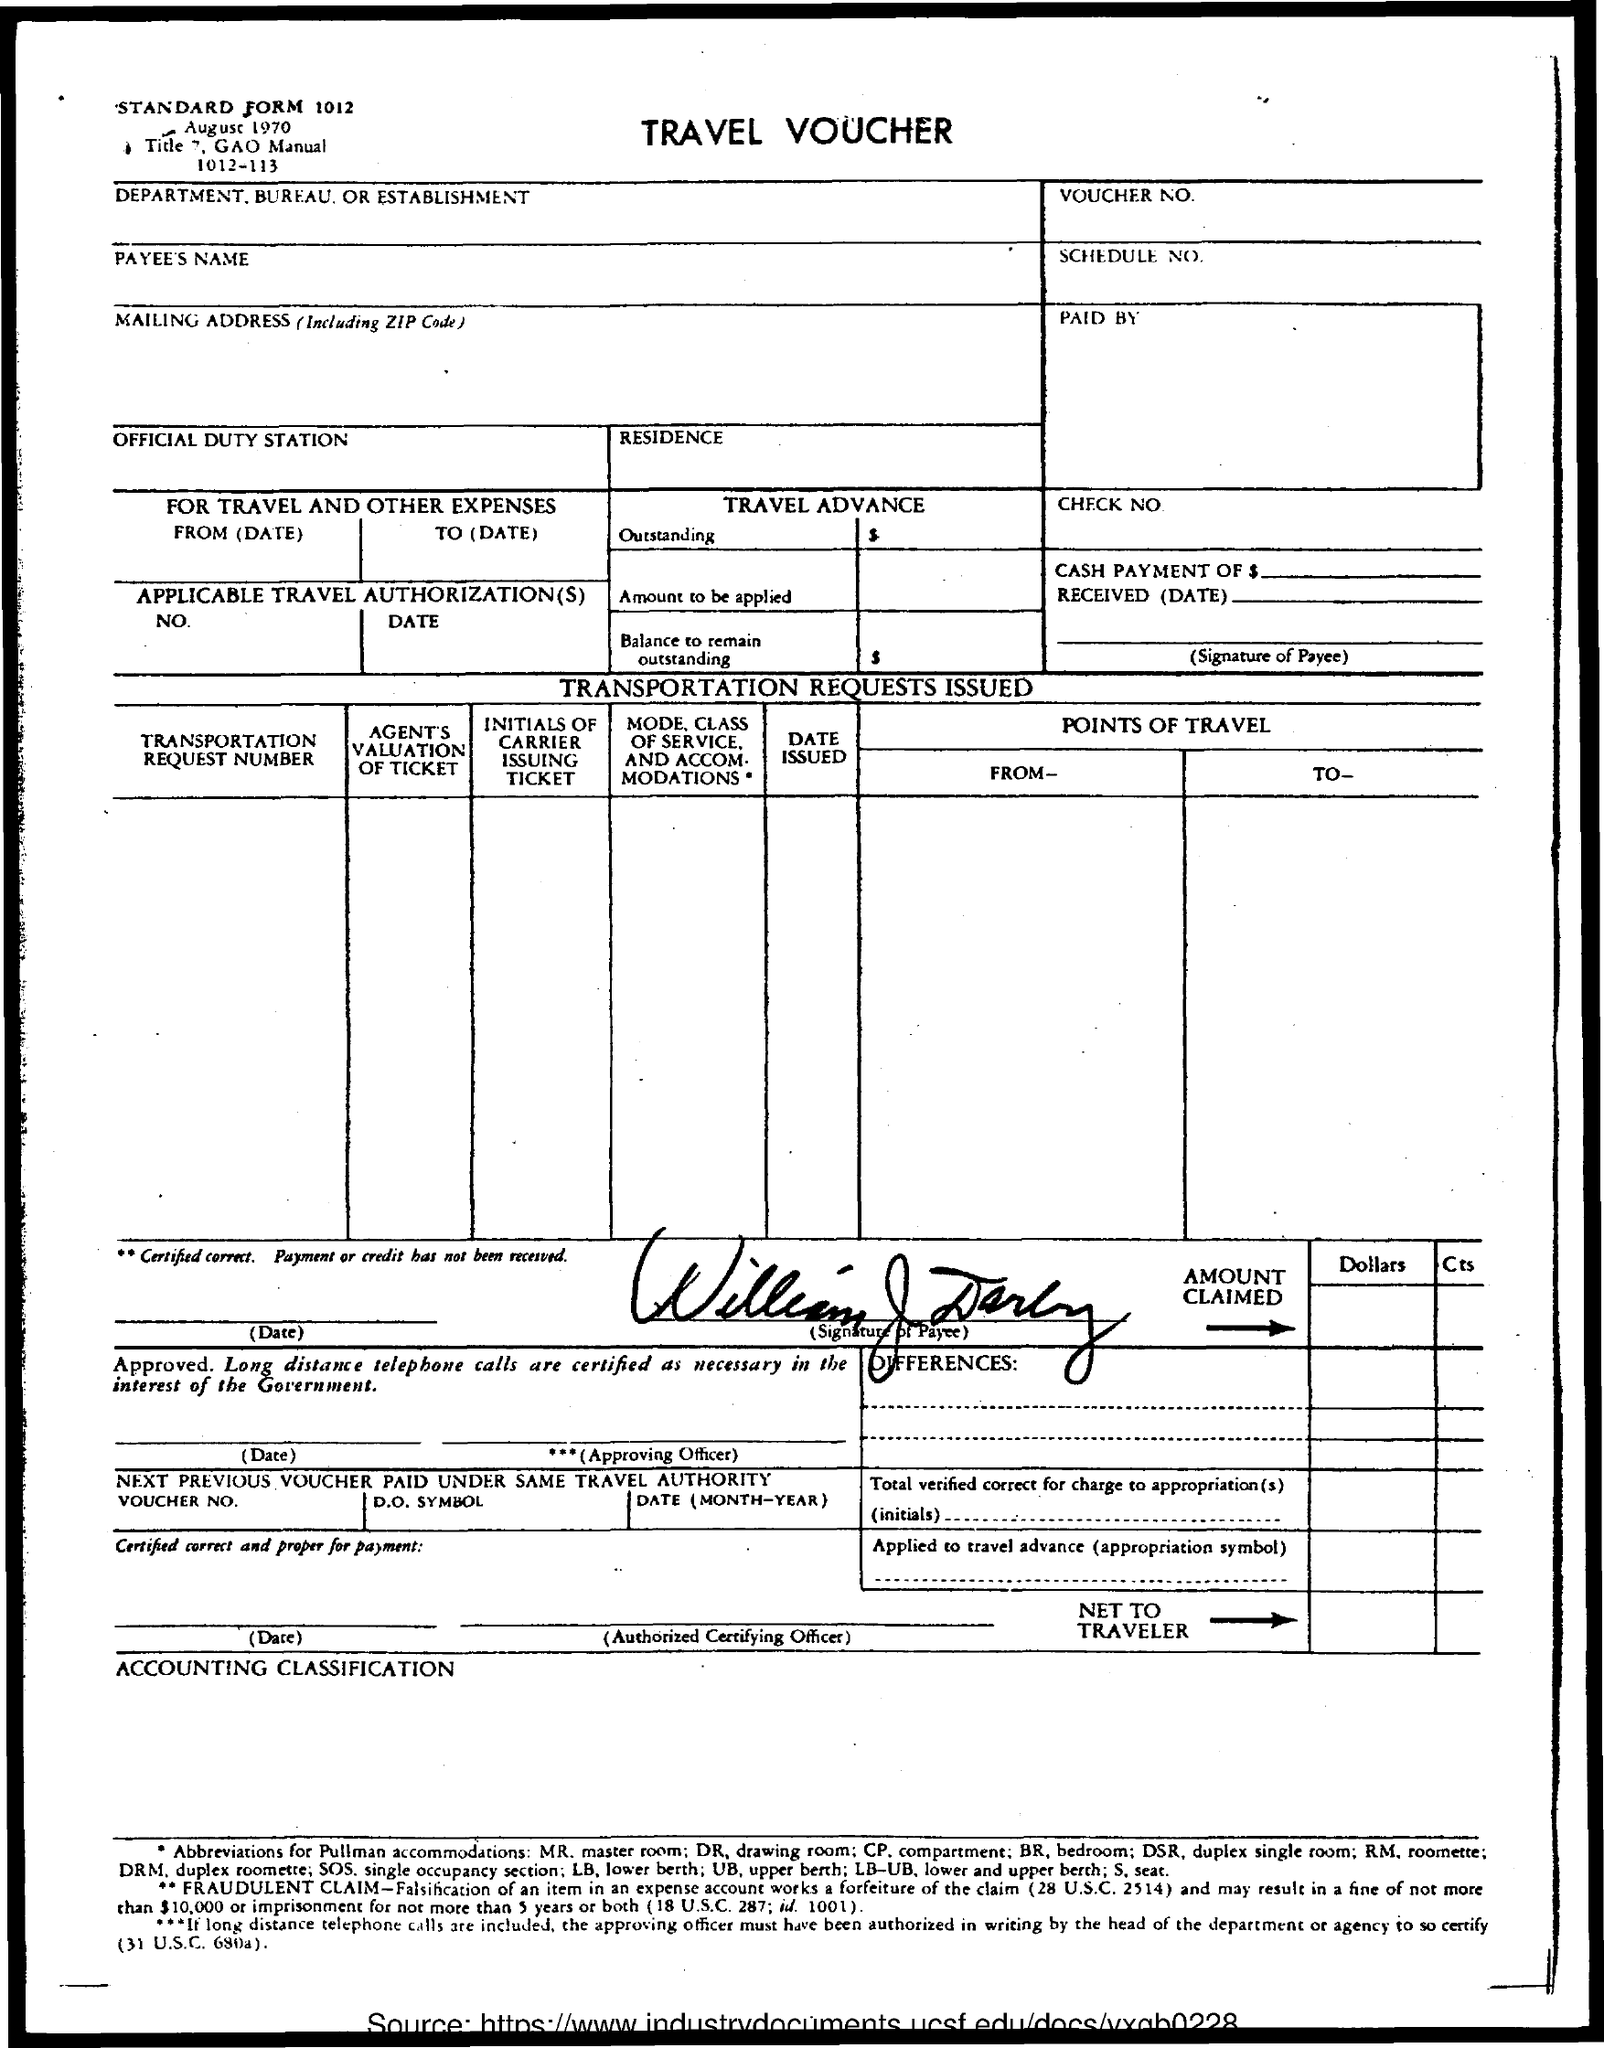What is the date mentioned in the document?
Offer a very short reply. August 1970. 